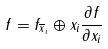Convert formula to latex. <formula><loc_0><loc_0><loc_500><loc_500>f = f _ { \overline { x } _ { i } } \oplus x _ { i } \frac { \partial f } { \partial x _ { i } }</formula> 